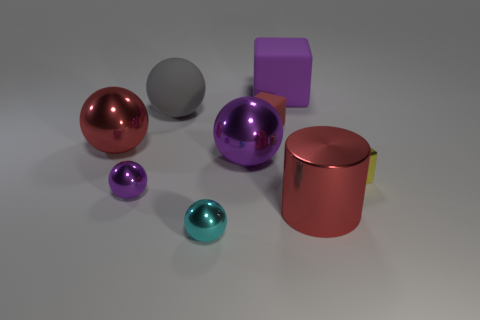Subtract all big red balls. How many balls are left? 4 Subtract 2 spheres. How many spheres are left? 3 Subtract all gray balls. How many balls are left? 4 Subtract all yellow balls. Subtract all blue cylinders. How many balls are left? 5 Subtract all cylinders. How many objects are left? 8 Add 4 purple blocks. How many purple blocks are left? 5 Add 9 large gray balls. How many large gray balls exist? 10 Subtract 0 cyan blocks. How many objects are left? 9 Subtract all big gray things. Subtract all yellow metallic cubes. How many objects are left? 7 